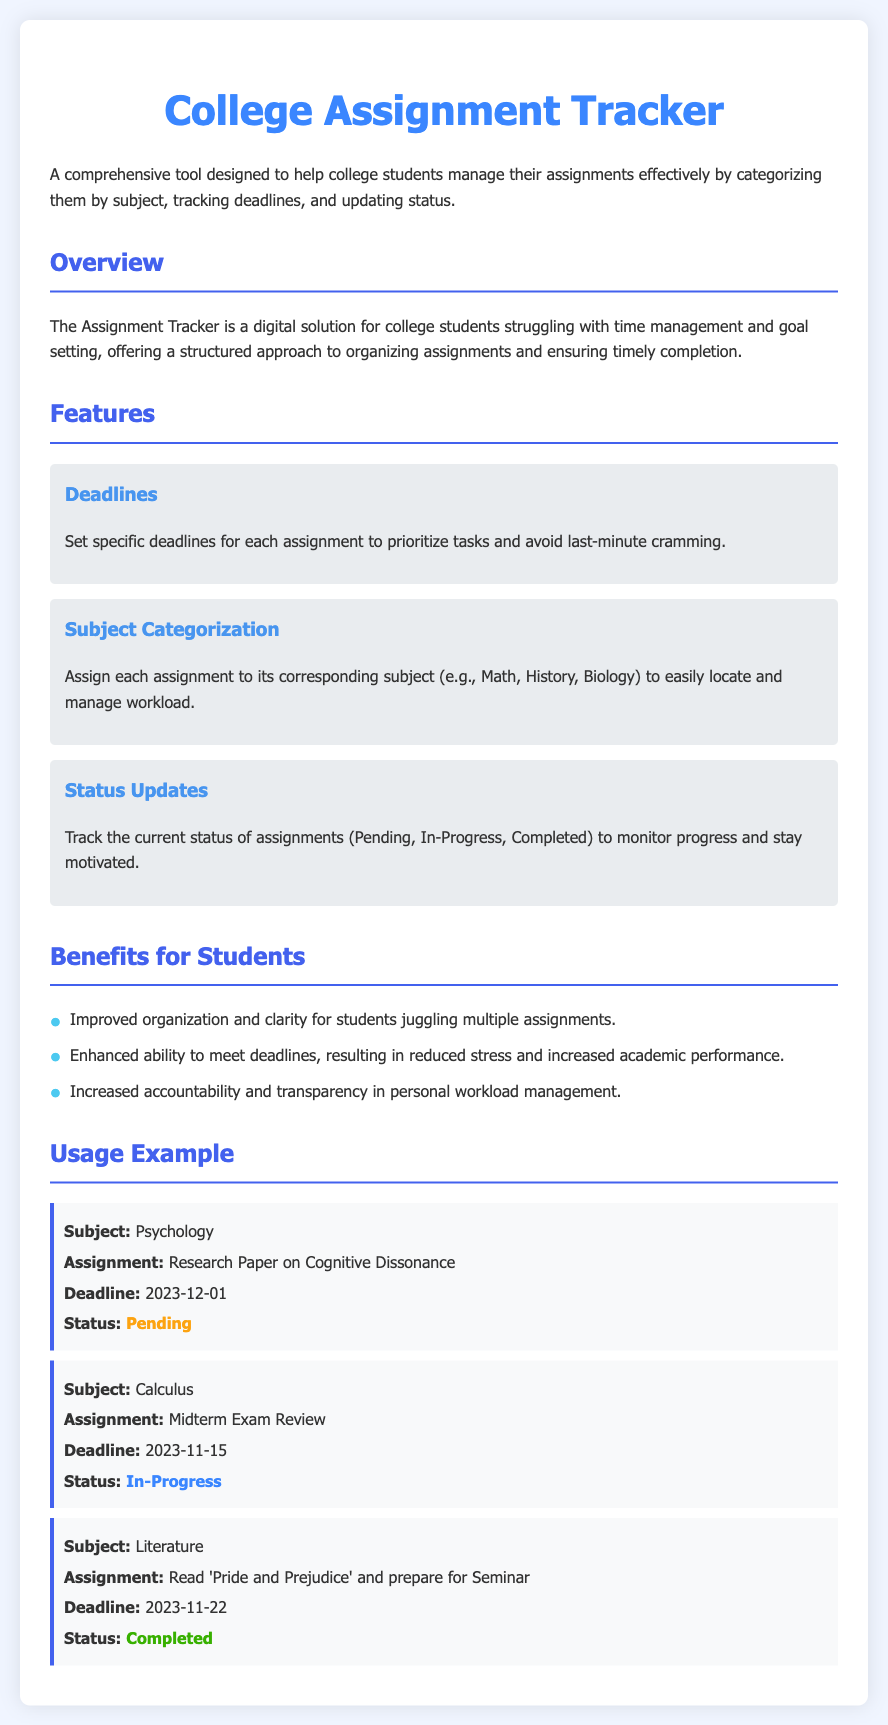What is the main title of the document? The main title of the document is prominently displayed at the top.
Answer: College Assignment Tracker What is the deadline for the Research Paper on Cognitive Dissonance? The deadline is listed under the assignment in the usage example section.
Answer: 2023-12-01 What status is assigned to the Midterm Exam Review? The status is specified for each assignment, showing current progress.
Answer: In-Progress Which subject does the completed assignment belong to? The document lists each completed assignment with its corresponding subject.
Answer: Literature What benefit does the Assignment Tracker provide for students? The benefits for students are detailed in a list format within the document.
Answer: Improved organization How many assignments are shown in the usage example? The usage example section contains three assignments.
Answer: Three What color represents the status of completed assignments? The document uses different colors to represent assignment statuses visually.
Answer: Green What is the purpose of the subject categorization feature? This feature is explained in relation to organizing assignments effectively.
Answer: To easily locate and manage workload 